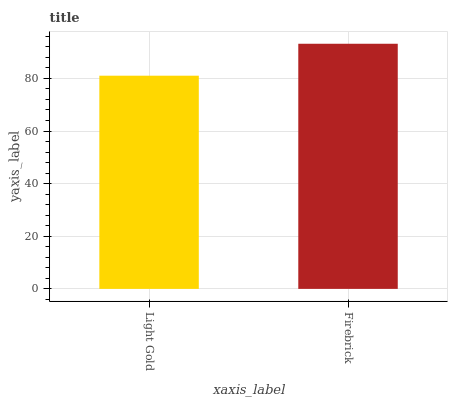Is Light Gold the minimum?
Answer yes or no. Yes. Is Firebrick the maximum?
Answer yes or no. Yes. Is Firebrick the minimum?
Answer yes or no. No. Is Firebrick greater than Light Gold?
Answer yes or no. Yes. Is Light Gold less than Firebrick?
Answer yes or no. Yes. Is Light Gold greater than Firebrick?
Answer yes or no. No. Is Firebrick less than Light Gold?
Answer yes or no. No. Is Firebrick the high median?
Answer yes or no. Yes. Is Light Gold the low median?
Answer yes or no. Yes. Is Light Gold the high median?
Answer yes or no. No. Is Firebrick the low median?
Answer yes or no. No. 